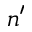Convert formula to latex. <formula><loc_0><loc_0><loc_500><loc_500>n ^ { \prime }</formula> 